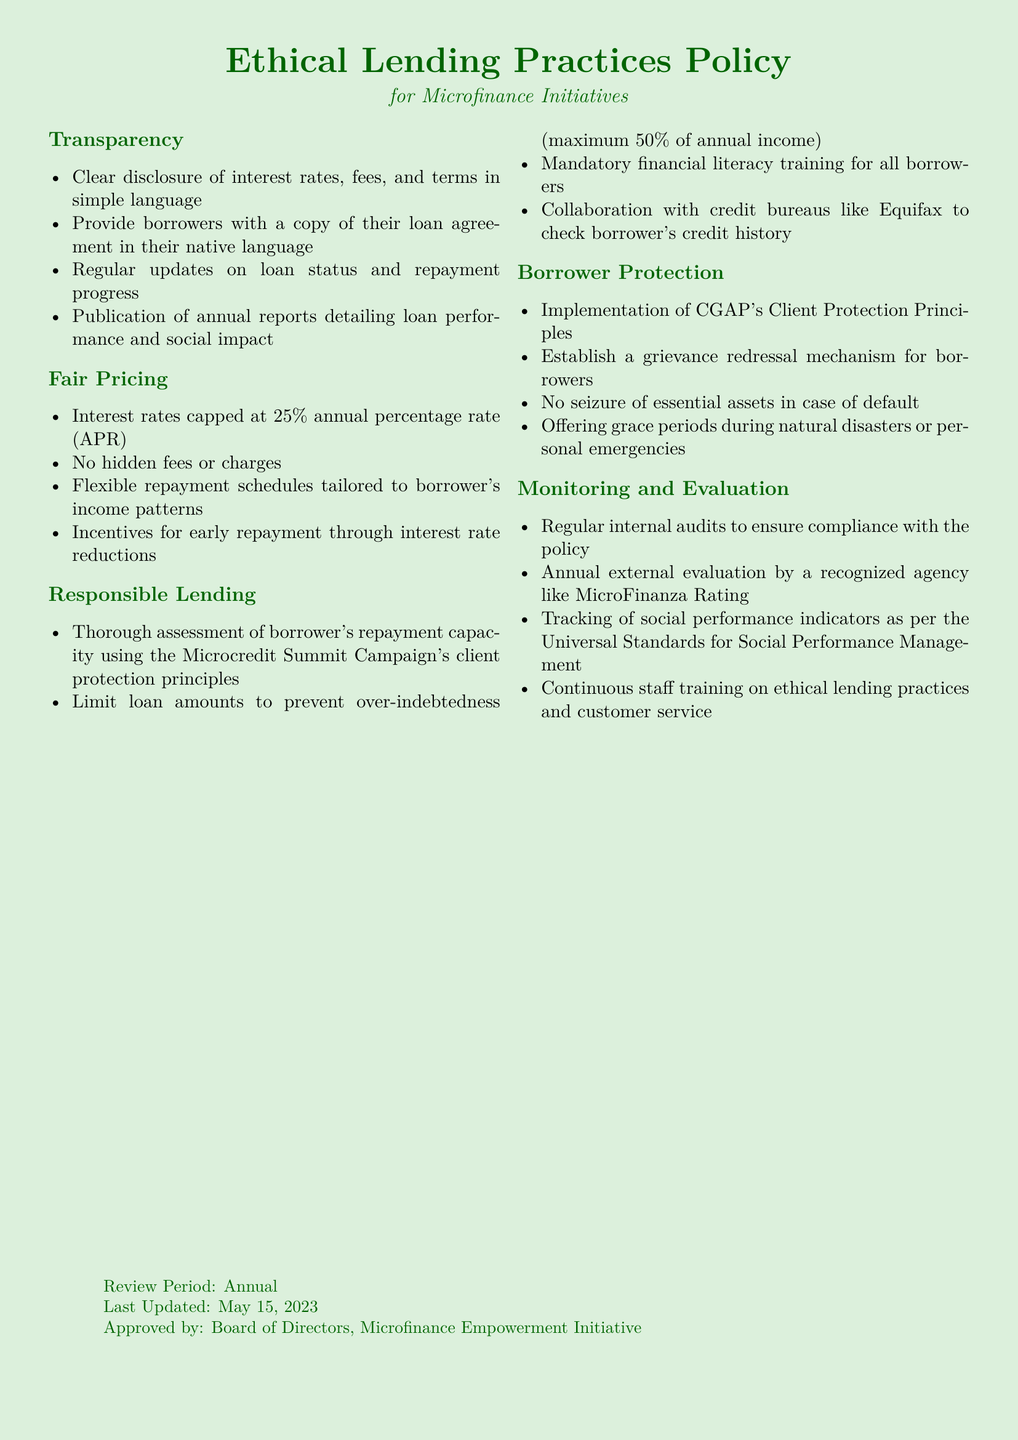what is the maximum annual percentage rate allowed? The policy states that interest rates are capped at 25 percent annual percentage rate.
Answer: 25 percent what is the grace period provision during emergencies? The document mentions offering grace periods during natural disasters or personal emergencies.
Answer: Grace periods what is required before offering loans to borrowers? The policy mandates the thorough assessment of borrower's repayment capacity using the Microcredit Summit Campaign's client protection principles.
Answer: Assessment of repayment capacity how often will the internal audits be conducted? The policy states that regular internal audits will be conducted to ensure compliance with the policy.
Answer: Regularly what is the purpose of the grievance redressal mechanism? The mechanism is established for borrowers to address their complaints or issues, as outlined in the Borrower Protection section.
Answer: Addressing borrower complaints what is the percentage of annual income that limits loan amounts? The document specifies that loan amounts are limited to prevent over-indebtedness, set at a maximum of 50 percent of annual income.
Answer: 50 percent who approved the Ethical Lending Practices Policy? The document indicates that it was approved by the Board of Directors of the Microfinance Empowerment Initiative.
Answer: Board of Directors what is one incentive mentioned for early repayment? The policy mentions providing incentives for early repayment through interest rate reductions.
Answer: Interest rate reductions 